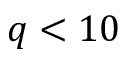<formula> <loc_0><loc_0><loc_500><loc_500>q < 1 0</formula> 